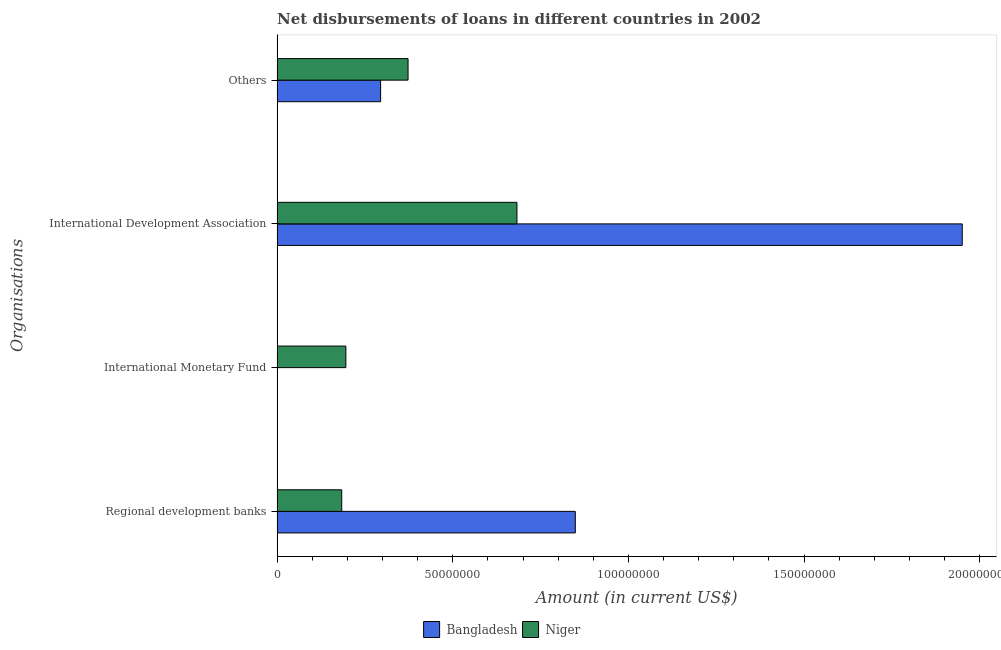Are the number of bars per tick equal to the number of legend labels?
Provide a succinct answer. No. How many bars are there on the 4th tick from the bottom?
Make the answer very short. 2. What is the label of the 4th group of bars from the top?
Offer a terse response. Regional development banks. What is the amount of loan disimbursed by regional development banks in Niger?
Your answer should be compact. 1.84e+07. Across all countries, what is the maximum amount of loan disimbursed by international development association?
Your answer should be compact. 1.95e+08. Across all countries, what is the minimum amount of loan disimbursed by international development association?
Provide a succinct answer. 6.83e+07. In which country was the amount of loan disimbursed by international monetary fund maximum?
Keep it short and to the point. Niger. What is the total amount of loan disimbursed by international development association in the graph?
Provide a short and direct response. 2.63e+08. What is the difference between the amount of loan disimbursed by international development association in Bangladesh and that in Niger?
Keep it short and to the point. 1.27e+08. What is the difference between the amount of loan disimbursed by international development association in Niger and the amount of loan disimbursed by other organisations in Bangladesh?
Your response must be concise. 3.88e+07. What is the average amount of loan disimbursed by international development association per country?
Your answer should be very brief. 1.32e+08. What is the difference between the amount of loan disimbursed by other organisations and amount of loan disimbursed by international development association in Niger?
Offer a terse response. -3.10e+07. What is the ratio of the amount of loan disimbursed by international development association in Bangladesh to that in Niger?
Your answer should be very brief. 2.86. Is the amount of loan disimbursed by other organisations in Niger less than that in Bangladesh?
Keep it short and to the point. No. Is the difference between the amount of loan disimbursed by international development association in Bangladesh and Niger greater than the difference between the amount of loan disimbursed by regional development banks in Bangladesh and Niger?
Provide a short and direct response. Yes. What is the difference between the highest and the second highest amount of loan disimbursed by international development association?
Make the answer very short. 1.27e+08. What is the difference between the highest and the lowest amount of loan disimbursed by international development association?
Offer a very short reply. 1.27e+08. Is it the case that in every country, the sum of the amount of loan disimbursed by regional development banks and amount of loan disimbursed by international monetary fund is greater than the amount of loan disimbursed by international development association?
Ensure brevity in your answer.  No. How many bars are there?
Make the answer very short. 7. Are all the bars in the graph horizontal?
Your response must be concise. Yes. How many countries are there in the graph?
Your answer should be very brief. 2. What is the difference between two consecutive major ticks on the X-axis?
Your answer should be compact. 5.00e+07. Are the values on the major ticks of X-axis written in scientific E-notation?
Offer a terse response. No. Does the graph contain grids?
Your answer should be compact. No. Where does the legend appear in the graph?
Keep it short and to the point. Bottom center. How many legend labels are there?
Your response must be concise. 2. How are the legend labels stacked?
Give a very brief answer. Horizontal. What is the title of the graph?
Your response must be concise. Net disbursements of loans in different countries in 2002. Does "United States" appear as one of the legend labels in the graph?
Your answer should be very brief. No. What is the label or title of the Y-axis?
Offer a very short reply. Organisations. What is the Amount (in current US$) of Bangladesh in Regional development banks?
Your answer should be compact. 8.49e+07. What is the Amount (in current US$) of Niger in Regional development banks?
Provide a succinct answer. 1.84e+07. What is the Amount (in current US$) of Niger in International Monetary Fund?
Offer a very short reply. 1.96e+07. What is the Amount (in current US$) of Bangladesh in International Development Association?
Ensure brevity in your answer.  1.95e+08. What is the Amount (in current US$) in Niger in International Development Association?
Your response must be concise. 6.83e+07. What is the Amount (in current US$) of Bangladesh in Others?
Offer a terse response. 2.95e+07. What is the Amount (in current US$) of Niger in Others?
Provide a short and direct response. 3.73e+07. Across all Organisations, what is the maximum Amount (in current US$) in Bangladesh?
Keep it short and to the point. 1.95e+08. Across all Organisations, what is the maximum Amount (in current US$) of Niger?
Offer a terse response. 6.83e+07. Across all Organisations, what is the minimum Amount (in current US$) of Niger?
Provide a short and direct response. 1.84e+07. What is the total Amount (in current US$) of Bangladesh in the graph?
Your answer should be very brief. 3.09e+08. What is the total Amount (in current US$) in Niger in the graph?
Your response must be concise. 1.44e+08. What is the difference between the Amount (in current US$) of Niger in Regional development banks and that in International Monetary Fund?
Your answer should be compact. -1.18e+06. What is the difference between the Amount (in current US$) of Bangladesh in Regional development banks and that in International Development Association?
Offer a very short reply. -1.10e+08. What is the difference between the Amount (in current US$) in Niger in Regional development banks and that in International Development Association?
Provide a succinct answer. -4.99e+07. What is the difference between the Amount (in current US$) of Bangladesh in Regional development banks and that in Others?
Keep it short and to the point. 5.54e+07. What is the difference between the Amount (in current US$) of Niger in Regional development banks and that in Others?
Provide a succinct answer. -1.89e+07. What is the difference between the Amount (in current US$) of Niger in International Monetary Fund and that in International Development Association?
Your answer should be compact. -4.87e+07. What is the difference between the Amount (in current US$) in Niger in International Monetary Fund and that in Others?
Your answer should be compact. -1.77e+07. What is the difference between the Amount (in current US$) in Bangladesh in International Development Association and that in Others?
Provide a short and direct response. 1.66e+08. What is the difference between the Amount (in current US$) of Niger in International Development Association and that in Others?
Provide a succinct answer. 3.10e+07. What is the difference between the Amount (in current US$) of Bangladesh in Regional development banks and the Amount (in current US$) of Niger in International Monetary Fund?
Provide a short and direct response. 6.53e+07. What is the difference between the Amount (in current US$) of Bangladesh in Regional development banks and the Amount (in current US$) of Niger in International Development Association?
Keep it short and to the point. 1.66e+07. What is the difference between the Amount (in current US$) in Bangladesh in Regional development banks and the Amount (in current US$) in Niger in Others?
Give a very brief answer. 4.76e+07. What is the difference between the Amount (in current US$) in Bangladesh in International Development Association and the Amount (in current US$) in Niger in Others?
Offer a very short reply. 1.58e+08. What is the average Amount (in current US$) in Bangladesh per Organisations?
Provide a short and direct response. 7.73e+07. What is the average Amount (in current US$) in Niger per Organisations?
Your answer should be very brief. 3.59e+07. What is the difference between the Amount (in current US$) of Bangladesh and Amount (in current US$) of Niger in Regional development banks?
Give a very brief answer. 6.65e+07. What is the difference between the Amount (in current US$) of Bangladesh and Amount (in current US$) of Niger in International Development Association?
Provide a short and direct response. 1.27e+08. What is the difference between the Amount (in current US$) of Bangladesh and Amount (in current US$) of Niger in Others?
Your answer should be compact. -7.81e+06. What is the ratio of the Amount (in current US$) of Niger in Regional development banks to that in International Monetary Fund?
Provide a short and direct response. 0.94. What is the ratio of the Amount (in current US$) of Bangladesh in Regional development banks to that in International Development Association?
Give a very brief answer. 0.44. What is the ratio of the Amount (in current US$) in Niger in Regional development banks to that in International Development Association?
Your answer should be compact. 0.27. What is the ratio of the Amount (in current US$) in Bangladesh in Regional development banks to that in Others?
Make the answer very short. 2.88. What is the ratio of the Amount (in current US$) of Niger in Regional development banks to that in Others?
Your answer should be very brief. 0.49. What is the ratio of the Amount (in current US$) in Niger in International Monetary Fund to that in International Development Association?
Your answer should be compact. 0.29. What is the ratio of the Amount (in current US$) of Niger in International Monetary Fund to that in Others?
Your answer should be compact. 0.53. What is the ratio of the Amount (in current US$) in Bangladesh in International Development Association to that in Others?
Offer a terse response. 6.62. What is the ratio of the Amount (in current US$) of Niger in International Development Association to that in Others?
Ensure brevity in your answer.  1.83. What is the difference between the highest and the second highest Amount (in current US$) of Bangladesh?
Give a very brief answer. 1.10e+08. What is the difference between the highest and the second highest Amount (in current US$) of Niger?
Keep it short and to the point. 3.10e+07. What is the difference between the highest and the lowest Amount (in current US$) of Bangladesh?
Provide a short and direct response. 1.95e+08. What is the difference between the highest and the lowest Amount (in current US$) of Niger?
Make the answer very short. 4.99e+07. 